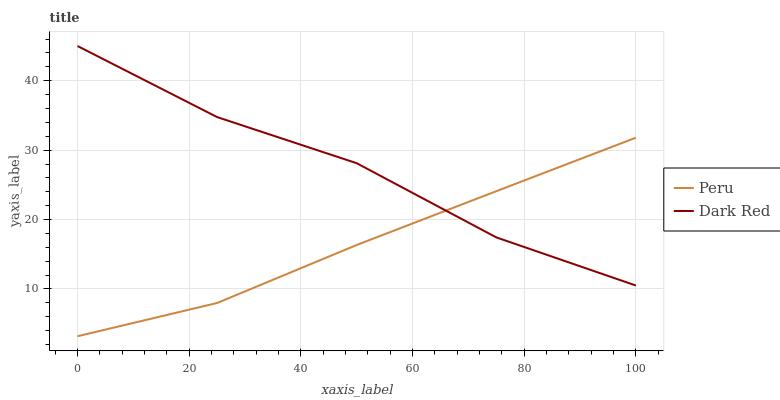Does Peru have the minimum area under the curve?
Answer yes or no. Yes. Does Dark Red have the maximum area under the curve?
Answer yes or no. Yes. Does Peru have the maximum area under the curve?
Answer yes or no. No. Is Peru the smoothest?
Answer yes or no. Yes. Is Dark Red the roughest?
Answer yes or no. Yes. Is Peru the roughest?
Answer yes or no. No. Does Peru have the lowest value?
Answer yes or no. Yes. Does Dark Red have the highest value?
Answer yes or no. Yes. Does Peru have the highest value?
Answer yes or no. No. Does Dark Red intersect Peru?
Answer yes or no. Yes. Is Dark Red less than Peru?
Answer yes or no. No. Is Dark Red greater than Peru?
Answer yes or no. No. 